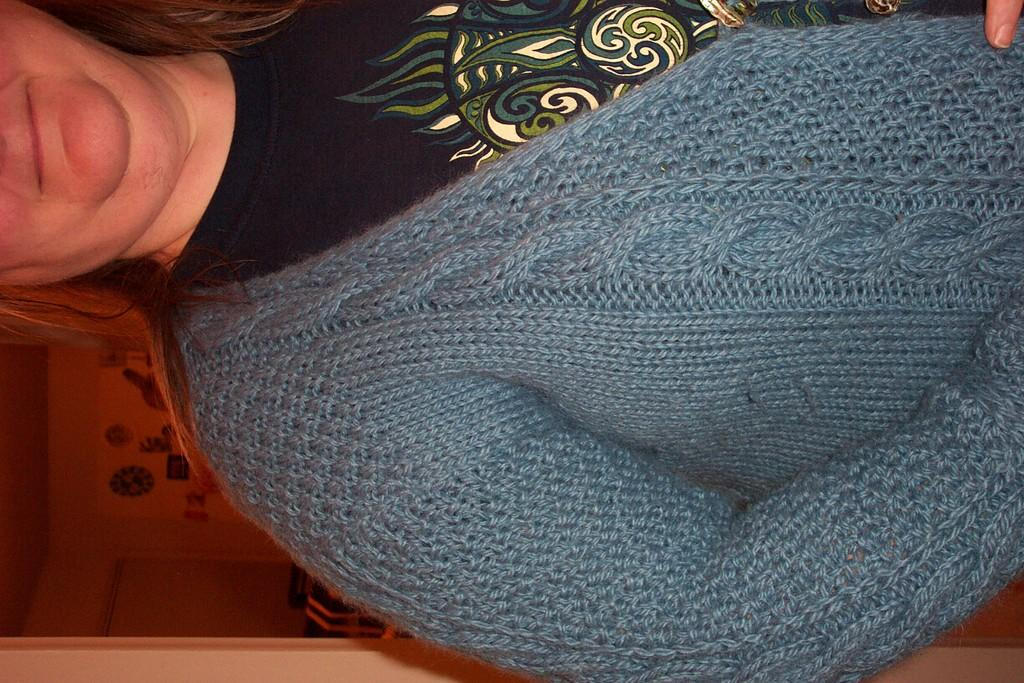Who is the main subject in the image? There is a woman in the image. What is the woman wearing? The woman is wearing a blue sweater. How much of the woman is visible in the image? Only half of the woman is visible. What can be seen behind the woman in the image? There is a room visible behind the woman. What type of wrench is the woman holding in the image? There is no wrench present in the image; the woman is not holding any tools. What color is the woman's hair in the image? The provided facts do not mention the color of the woman's hair, so we cannot determine that information from the image. 